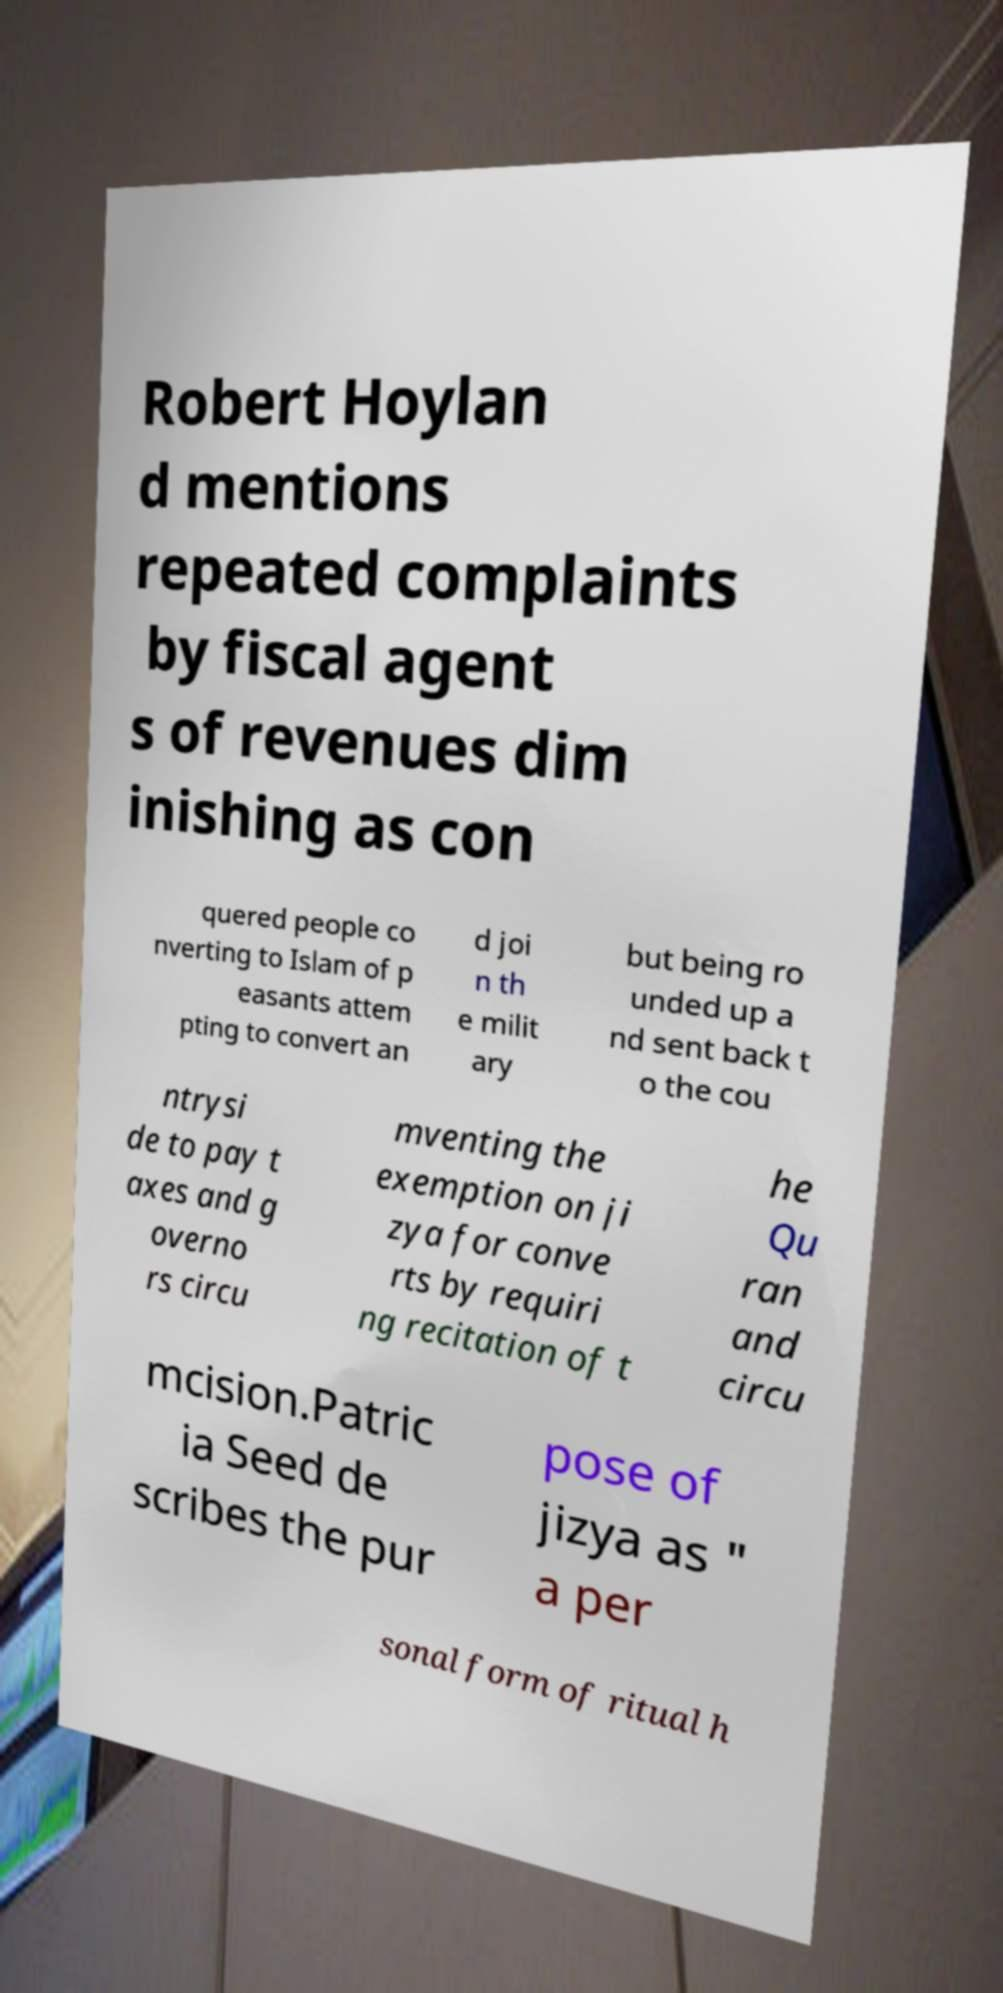Could you extract and type out the text from this image? Robert Hoylan d mentions repeated complaints by fiscal agent s of revenues dim inishing as con quered people co nverting to Islam of p easants attem pting to convert an d joi n th e milit ary but being ro unded up a nd sent back t o the cou ntrysi de to pay t axes and g overno rs circu mventing the exemption on ji zya for conve rts by requiri ng recitation of t he Qu ran and circu mcision.Patric ia Seed de scribes the pur pose of jizya as " a per sonal form of ritual h 